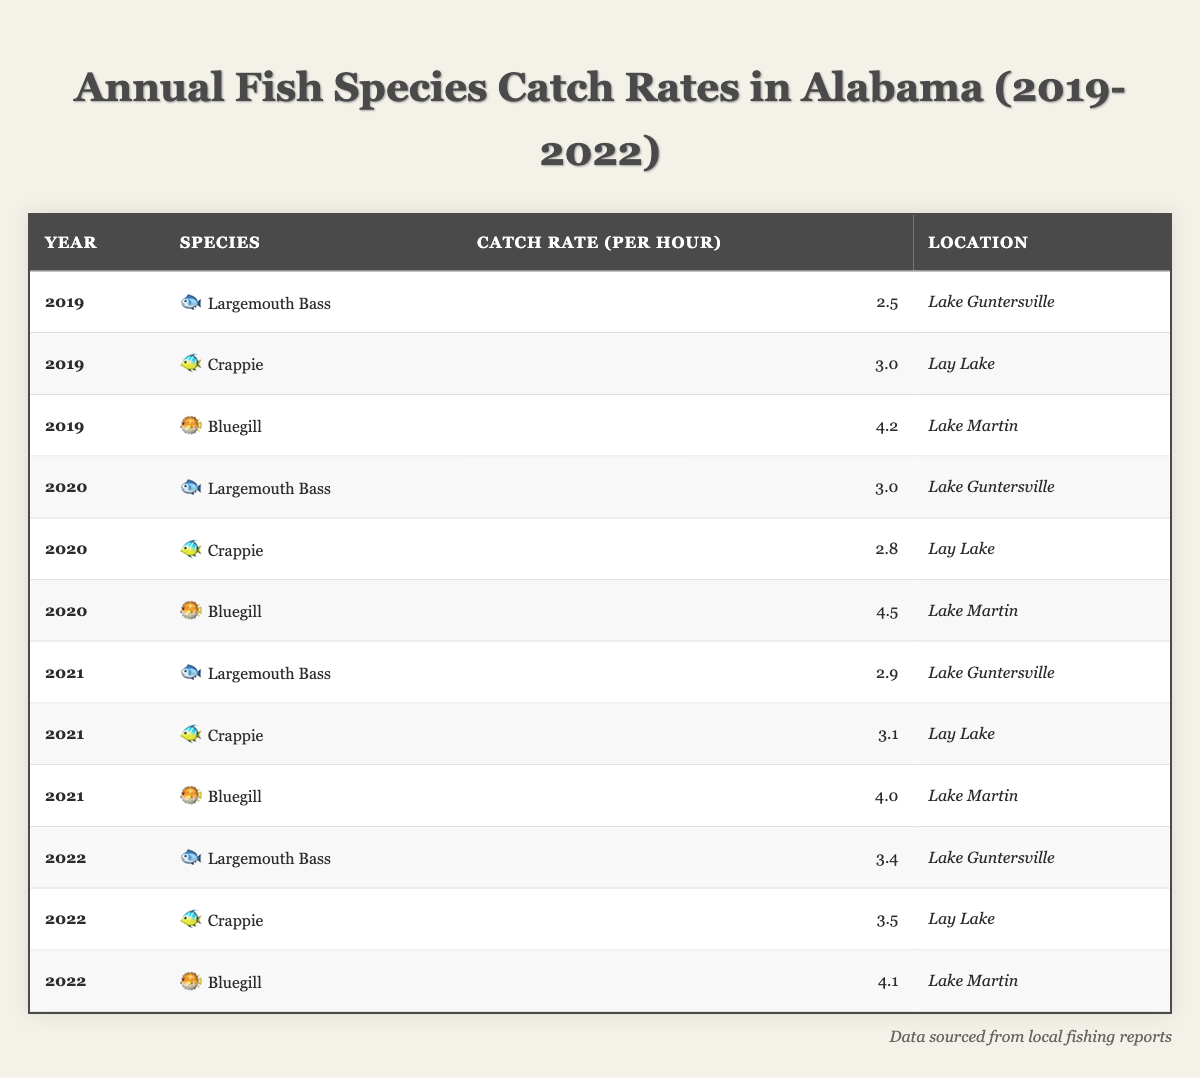What is the catch rate of Largemouth Bass in 2022? In the 2022 data, the table shows that the catch rate for Largemouth Bass is 3.4 per hour at Lake Guntersville.
Answer: 3.4 Which species had the highest catch rate in 2019? In 2019, the table indicates that Bluegill had the highest catch rate of 4.2 per hour at Lake Martin.
Answer: Bluegill What's the average catch rate of Crappie from 2019 to 2022? To find the average catch rate of Crappie from 2019 to 2022, add the catch rates (3.0 + 2.8 + 3.1 + 3.5) = 12.4, and divide by 4 years, which equals 12.4 / 4 = 3.1.
Answer: 3.1 Did the catch rate of Bluegill increase or decrease from 2019 to 2022? In 2019, the catch rate of Bluegill was 4.2, which decreased to 4.1 in 2022. This indicates a decrease in catch rate.
Answer: Decrease Which species showed the least variation in catch rate across the years? By reviewing the catch rates, Crappie shows small variation (3.0, 2.8, 3.1, 3.5), with a range of 0.7. Other species had larger differences. Thus, Crappie shows the least variation.
Answer: Crappie What is the difference in catch rates for Largemouth Bass between 2019 and 2022? The catch rate for Largemouth Bass in 2019 was 2.5, and in 2022 it was 3.4. The difference is 3.4 - 2.5 = 0.9.
Answer: 0.9 Was the highest catch rate ever recorded for Bluegill in 2020? The highest catch rate for Bluegill was 4.5 in 2020. We compare this with other years: 4.2 in 2019, 4.0 in 2021, and 4.1 in 2022. Thus, the highest was indeed in 2020.
Answer: Yes What was the catch rate trend for Largemouth Bass from 2019 to 2022? Reviewing the catch rates, Largemouth Bass started at 2.5 in 2019, increased to 3.0 in 2020, then slightly decreased to 2.9 in 2021, and rose again to 3.4 in 2022. The trend is overall increasing, with some fluctuation.
Answer: Increasing How many species were reported for Lake Martin in 2021? A look at the table shows that in 2021, there was one entry for Bluegill. Hence, the number of species reported is one.
Answer: 1 What is the total catch rate for all species in 2020? To find the total catch rate in 2020, add the catch rates for each species in that year: 3.0 (Largemouth Bass) + 2.8 (Crappie) + 4.5 (Bluegill) = 10.3.
Answer: 10.3 